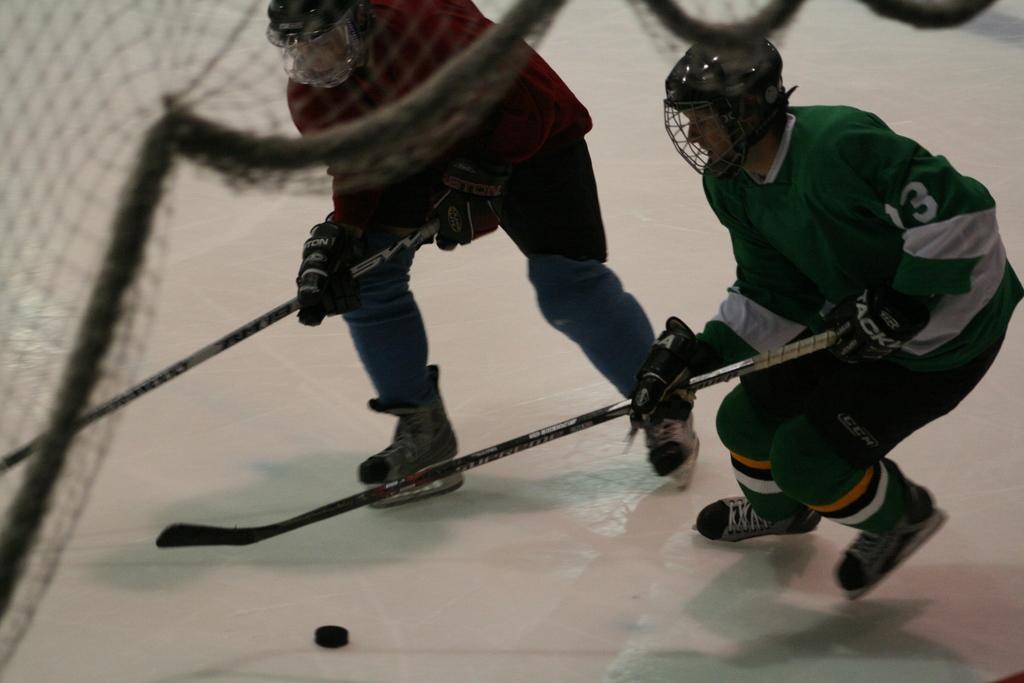Can you describe this image briefly? In this image, we can see two people are wearing skating shoes and holding sticks. They are playing a game on the white surface. At the bottom of the image, we can see black color object on the surface. Here we can see a net. 